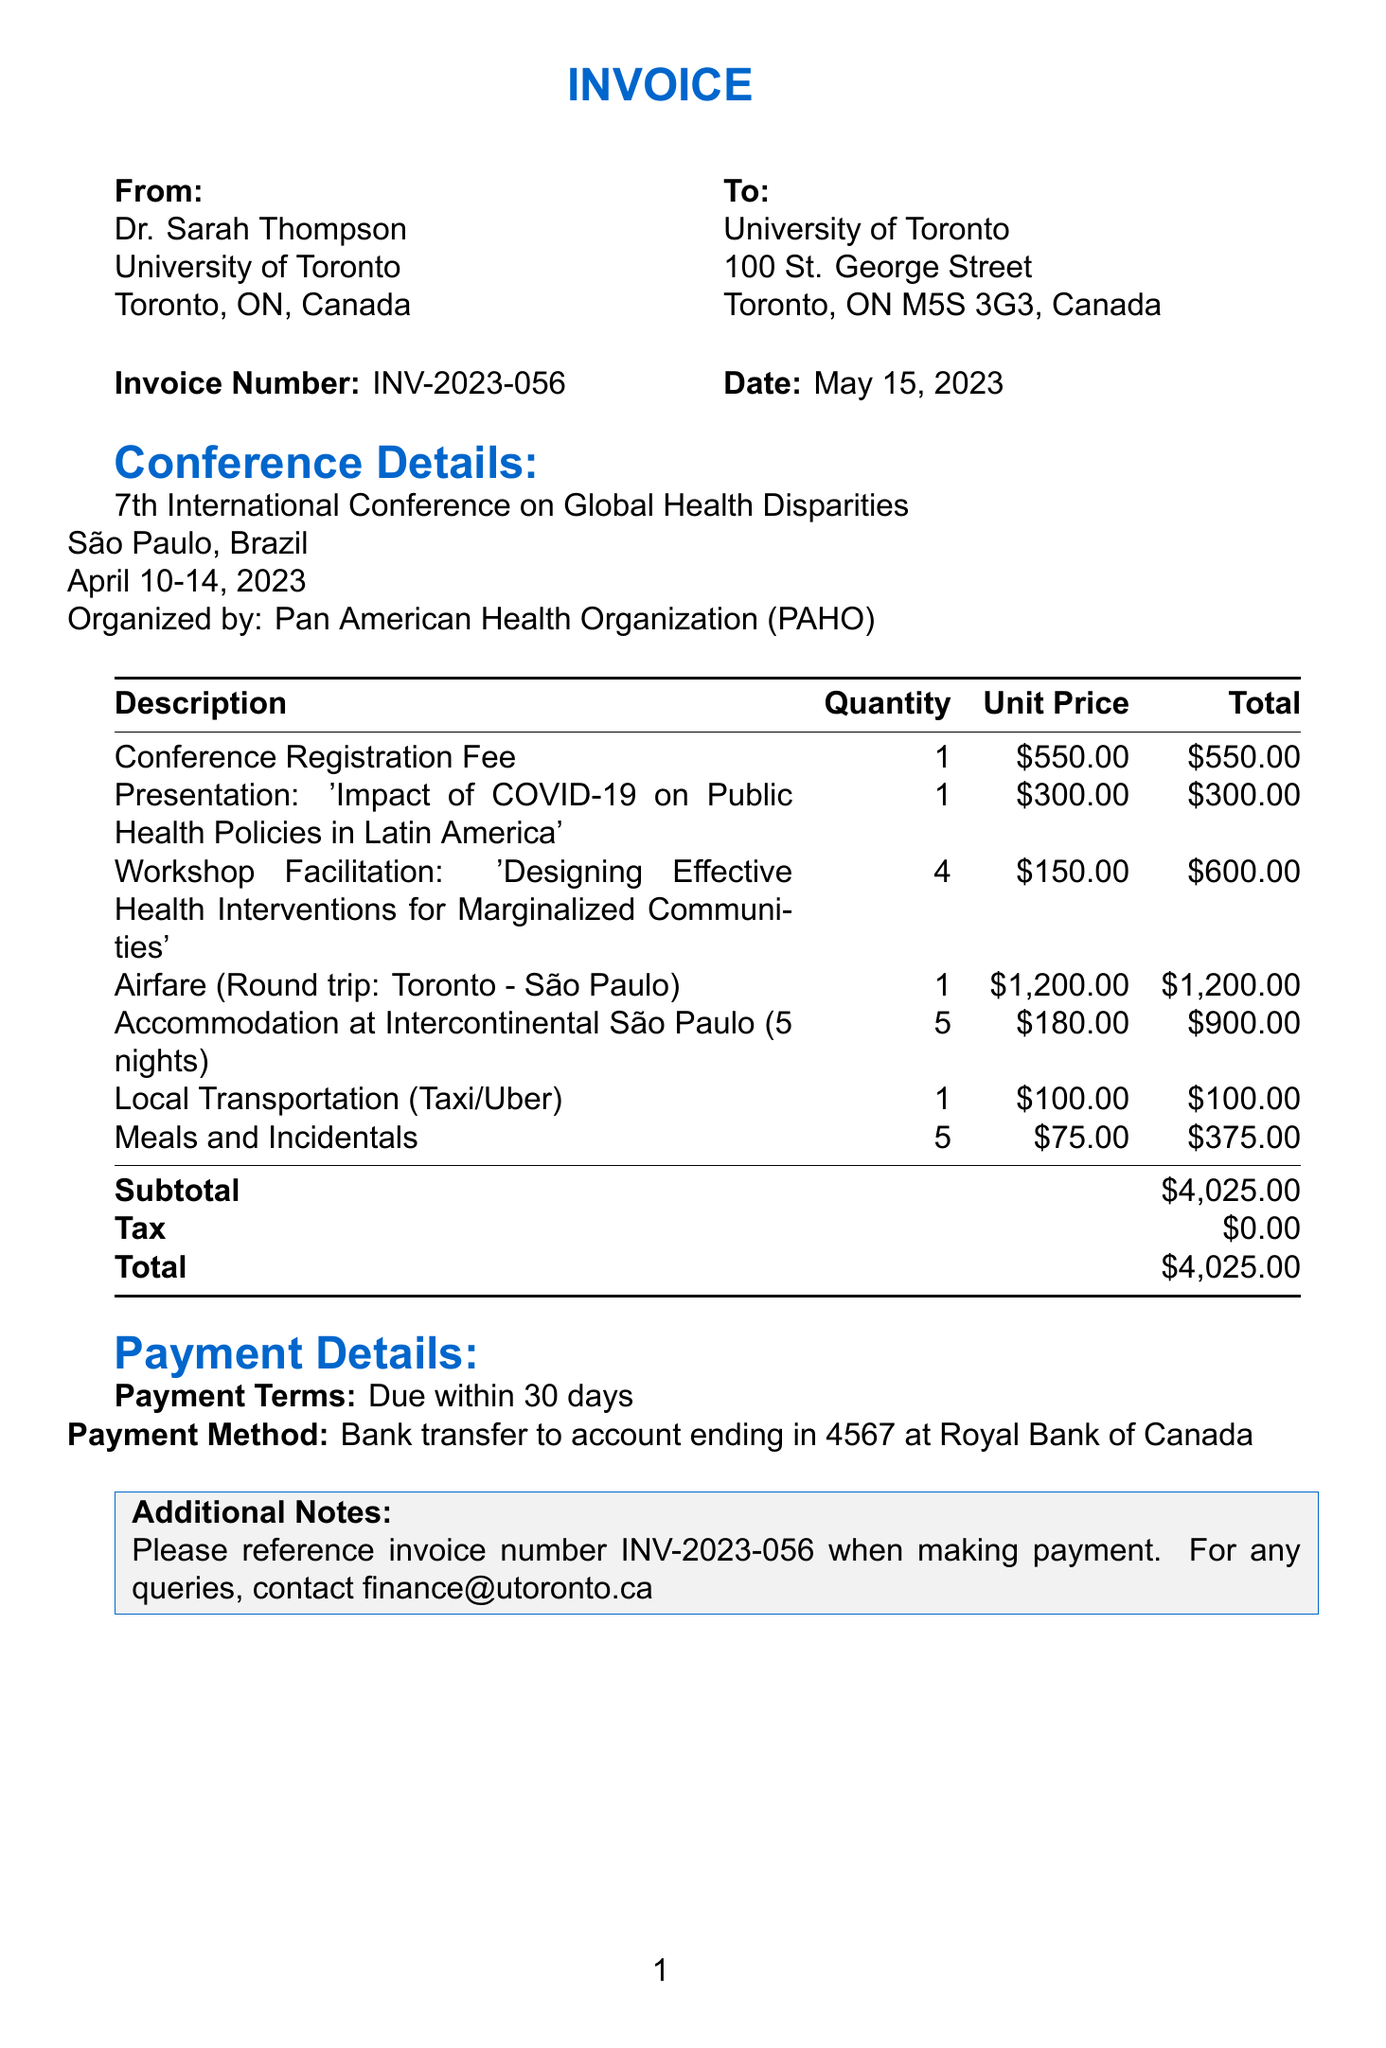What is the invoice number? The invoice number is prominently displayed in the document and can be found in the "Invoice Number" section.
Answer: INV-2023-056 Who is the client? The client is identified in the document under the "To" section, listing both the name and the institution.
Answer: Dr. Sarah Thompson What is the total amount due? The total amount can be found at the bottom of the line items table, representing the full sum requested.
Answer: $4,025.00 How many nights of accommodation are charged? The quantity of nights charged is stated in the description of the accommodation line item.
Answer: 5 What is the date of the conference? The date of the conference is clearly mentioned in the section summarizing the conference details.
Answer: April 10-14, 2023 What is the payment method? The payment method is outlined in the "Payment Details" section specifically describing acceptable ways to settle the invoice.
Answer: Bank transfer to account ending in 4567 at Royal Bank of Canada What was the presentation title? The title of the presentation is detailed in the description of the relevant line item.
Answer: Impact of COVID-19 on Public Health Policies in Latin America How many workshops were facilitated? The number of workshops facilitated is noted in the workshop facilitation line item under "Quantity."
Answer: 4 What is the client's institution name? The client's institution name is mentioned directly underneath the client's name in the "To" section.
Answer: University of Toronto 